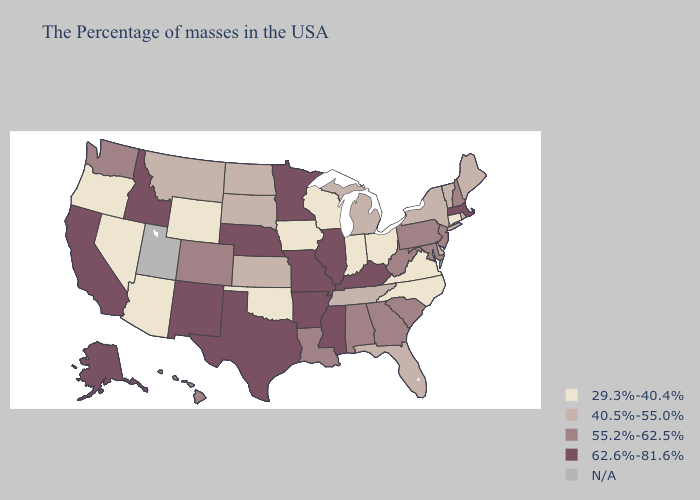Name the states that have a value in the range 62.6%-81.6%?
Short answer required. Massachusetts, Kentucky, Illinois, Mississippi, Missouri, Arkansas, Minnesota, Nebraska, Texas, New Mexico, Idaho, California, Alaska. What is the highest value in states that border Florida?
Be succinct. 55.2%-62.5%. What is the lowest value in the Northeast?
Keep it brief. 29.3%-40.4%. Name the states that have a value in the range 40.5%-55.0%?
Answer briefly. Maine, Rhode Island, Vermont, New York, Delaware, Florida, Michigan, Tennessee, Kansas, South Dakota, North Dakota, Montana. Among the states that border Nebraska , does Missouri have the highest value?
Keep it brief. Yes. Among the states that border Alabama , which have the lowest value?
Give a very brief answer. Florida, Tennessee. Is the legend a continuous bar?
Answer briefly. No. Does the map have missing data?
Write a very short answer. Yes. Does Florida have the highest value in the USA?
Write a very short answer. No. Name the states that have a value in the range 29.3%-40.4%?
Concise answer only. Connecticut, Virginia, North Carolina, Ohio, Indiana, Wisconsin, Iowa, Oklahoma, Wyoming, Arizona, Nevada, Oregon. Does New York have the lowest value in the USA?
Write a very short answer. No. What is the value of Kansas?
Keep it brief. 40.5%-55.0%. Is the legend a continuous bar?
Write a very short answer. No. Among the states that border Massachusetts , which have the highest value?
Give a very brief answer. New Hampshire. Name the states that have a value in the range 55.2%-62.5%?
Short answer required. New Hampshire, New Jersey, Maryland, Pennsylvania, South Carolina, West Virginia, Georgia, Alabama, Louisiana, Colorado, Washington, Hawaii. 